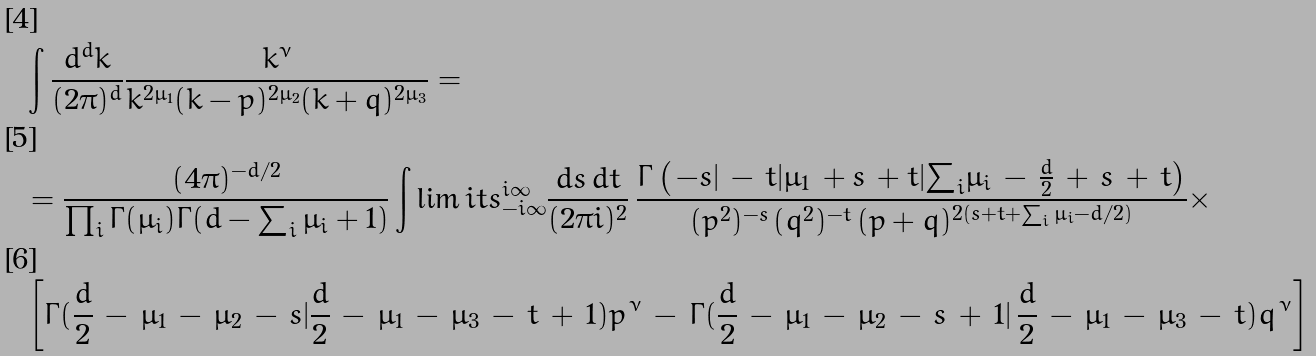Convert formula to latex. <formula><loc_0><loc_0><loc_500><loc_500>& \int \frac { d ^ { d } k } { ( 2 \pi ) ^ { d } } \frac { k ^ { \nu } } { k ^ { 2 \mu _ { 1 } } ( k - p ) ^ { 2 \mu _ { 2 } } ( k + q ) ^ { 2 \mu _ { 3 } } } = \\ & = \frac { ( 4 \pi ) ^ { - d / 2 } } { \prod _ { i } \Gamma ( \mu _ { i } ) \Gamma ( d - \sum _ { i } \mu _ { i } + 1 ) } \int \lim i t s _ { - i \infty } ^ { i \infty } \frac { d { s } \, d { t } } { ( 2 \pi i ) ^ { 2 } } \, \frac { \Gamma \left ( \, - { s } | \, - \, { t } | \mu _ { 1 } \, + { s } \, + { t } | { \sum } _ { i } \mu _ { i } \, - \, \frac { d } { 2 } \, + \, { s } \, + \, { t } \right ) } { ( p ^ { 2 } ) ^ { - { s } } \, ( q ^ { 2 } ) ^ { - { t } } \, ( p + q ) ^ { 2 ( { s } + { t } + \sum _ { i } \mu _ { i } - d / 2 ) } } \times \\ & \left [ \Gamma ( \frac { d } { 2 } \, - \, \mu _ { 1 } \, - \, \mu _ { 2 } \, - \, { s } | \frac { d } { 2 } \, - \, \mu _ { 1 } \, - \, \mu _ { 3 } \, - \, { t } \, + \, 1 ) p ^ { \, \nu } \, - \, \Gamma ( \frac { d } { 2 } \, - \, \mu _ { 1 } \, - \, \mu _ { 2 } \, - \, { s } \, + \, 1 | \, \frac { d } { 2 } \, - \, \mu _ { 1 } \, - \, \mu _ { 3 } \, - \, { t } ) q ^ { \, \nu } \right ]</formula> 